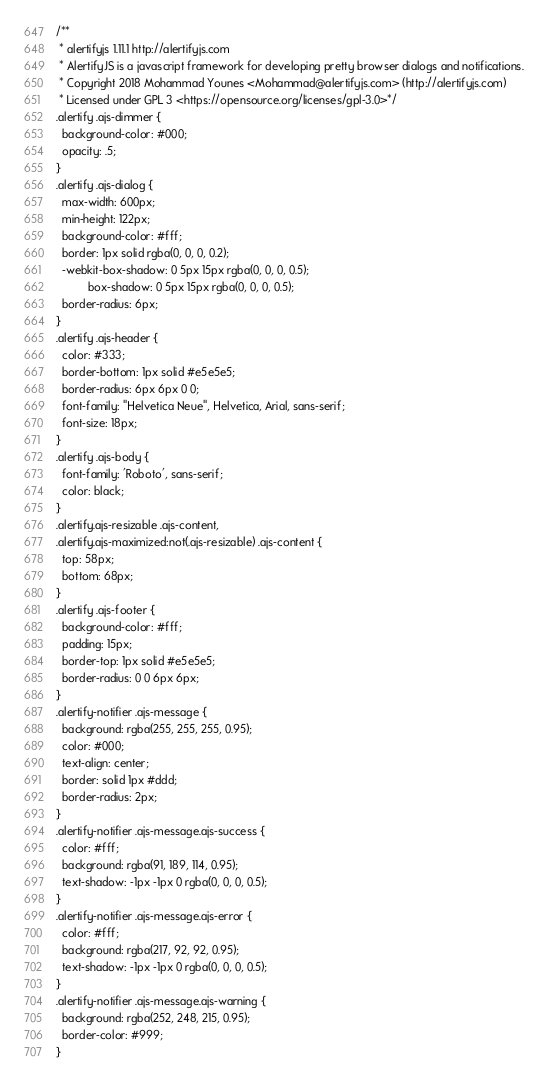Convert code to text. <code><loc_0><loc_0><loc_500><loc_500><_CSS_>/**
 * alertifyjs 1.11.1 http://alertifyjs.com
 * AlertifyJS is a javascript framework for developing pretty browser dialogs and notifications.
 * Copyright 2018 Mohammad Younes <Mohammad@alertifyjs.com> (http://alertifyjs.com) 
 * Licensed under GPL 3 <https://opensource.org/licenses/gpl-3.0>*/
.alertify .ajs-dimmer {
  background-color: #000;
  opacity: .5;
}
.alertify .ajs-dialog {
  max-width: 600px;
  min-height: 122px;
  background-color: #fff;
  border: 1px solid rgba(0, 0, 0, 0.2);
  -webkit-box-shadow: 0 5px 15px rgba(0, 0, 0, 0.5);
          box-shadow: 0 5px 15px rgba(0, 0, 0, 0.5);
  border-radius: 6px;
}
.alertify .ajs-header {
  color: #333;
  border-bottom: 1px solid #e5e5e5;
  border-radius: 6px 6px 0 0;
  font-family: "Helvetica Neue", Helvetica, Arial, sans-serif;
  font-size: 18px;
}
.alertify .ajs-body {
  font-family: 'Roboto', sans-serif;
  color: black;
}
.alertify.ajs-resizable .ajs-content,
.alertify.ajs-maximized:not(.ajs-resizable) .ajs-content {
  top: 58px;
  bottom: 68px;
}
.alertify .ajs-footer {
  background-color: #fff;
  padding: 15px;
  border-top: 1px solid #e5e5e5;
  border-radius: 0 0 6px 6px;
}
.alertify-notifier .ajs-message {
  background: rgba(255, 255, 255, 0.95);
  color: #000;
  text-align: center;
  border: solid 1px #ddd;
  border-radius: 2px;
}
.alertify-notifier .ajs-message.ajs-success {
  color: #fff;
  background: rgba(91, 189, 114, 0.95);
  text-shadow: -1px -1px 0 rgba(0, 0, 0, 0.5);
}
.alertify-notifier .ajs-message.ajs-error {
  color: #fff;
  background: rgba(217, 92, 92, 0.95);
  text-shadow: -1px -1px 0 rgba(0, 0, 0, 0.5);
}
.alertify-notifier .ajs-message.ajs-warning {
  background: rgba(252, 248, 215, 0.95);
  border-color: #999;
}
</code> 